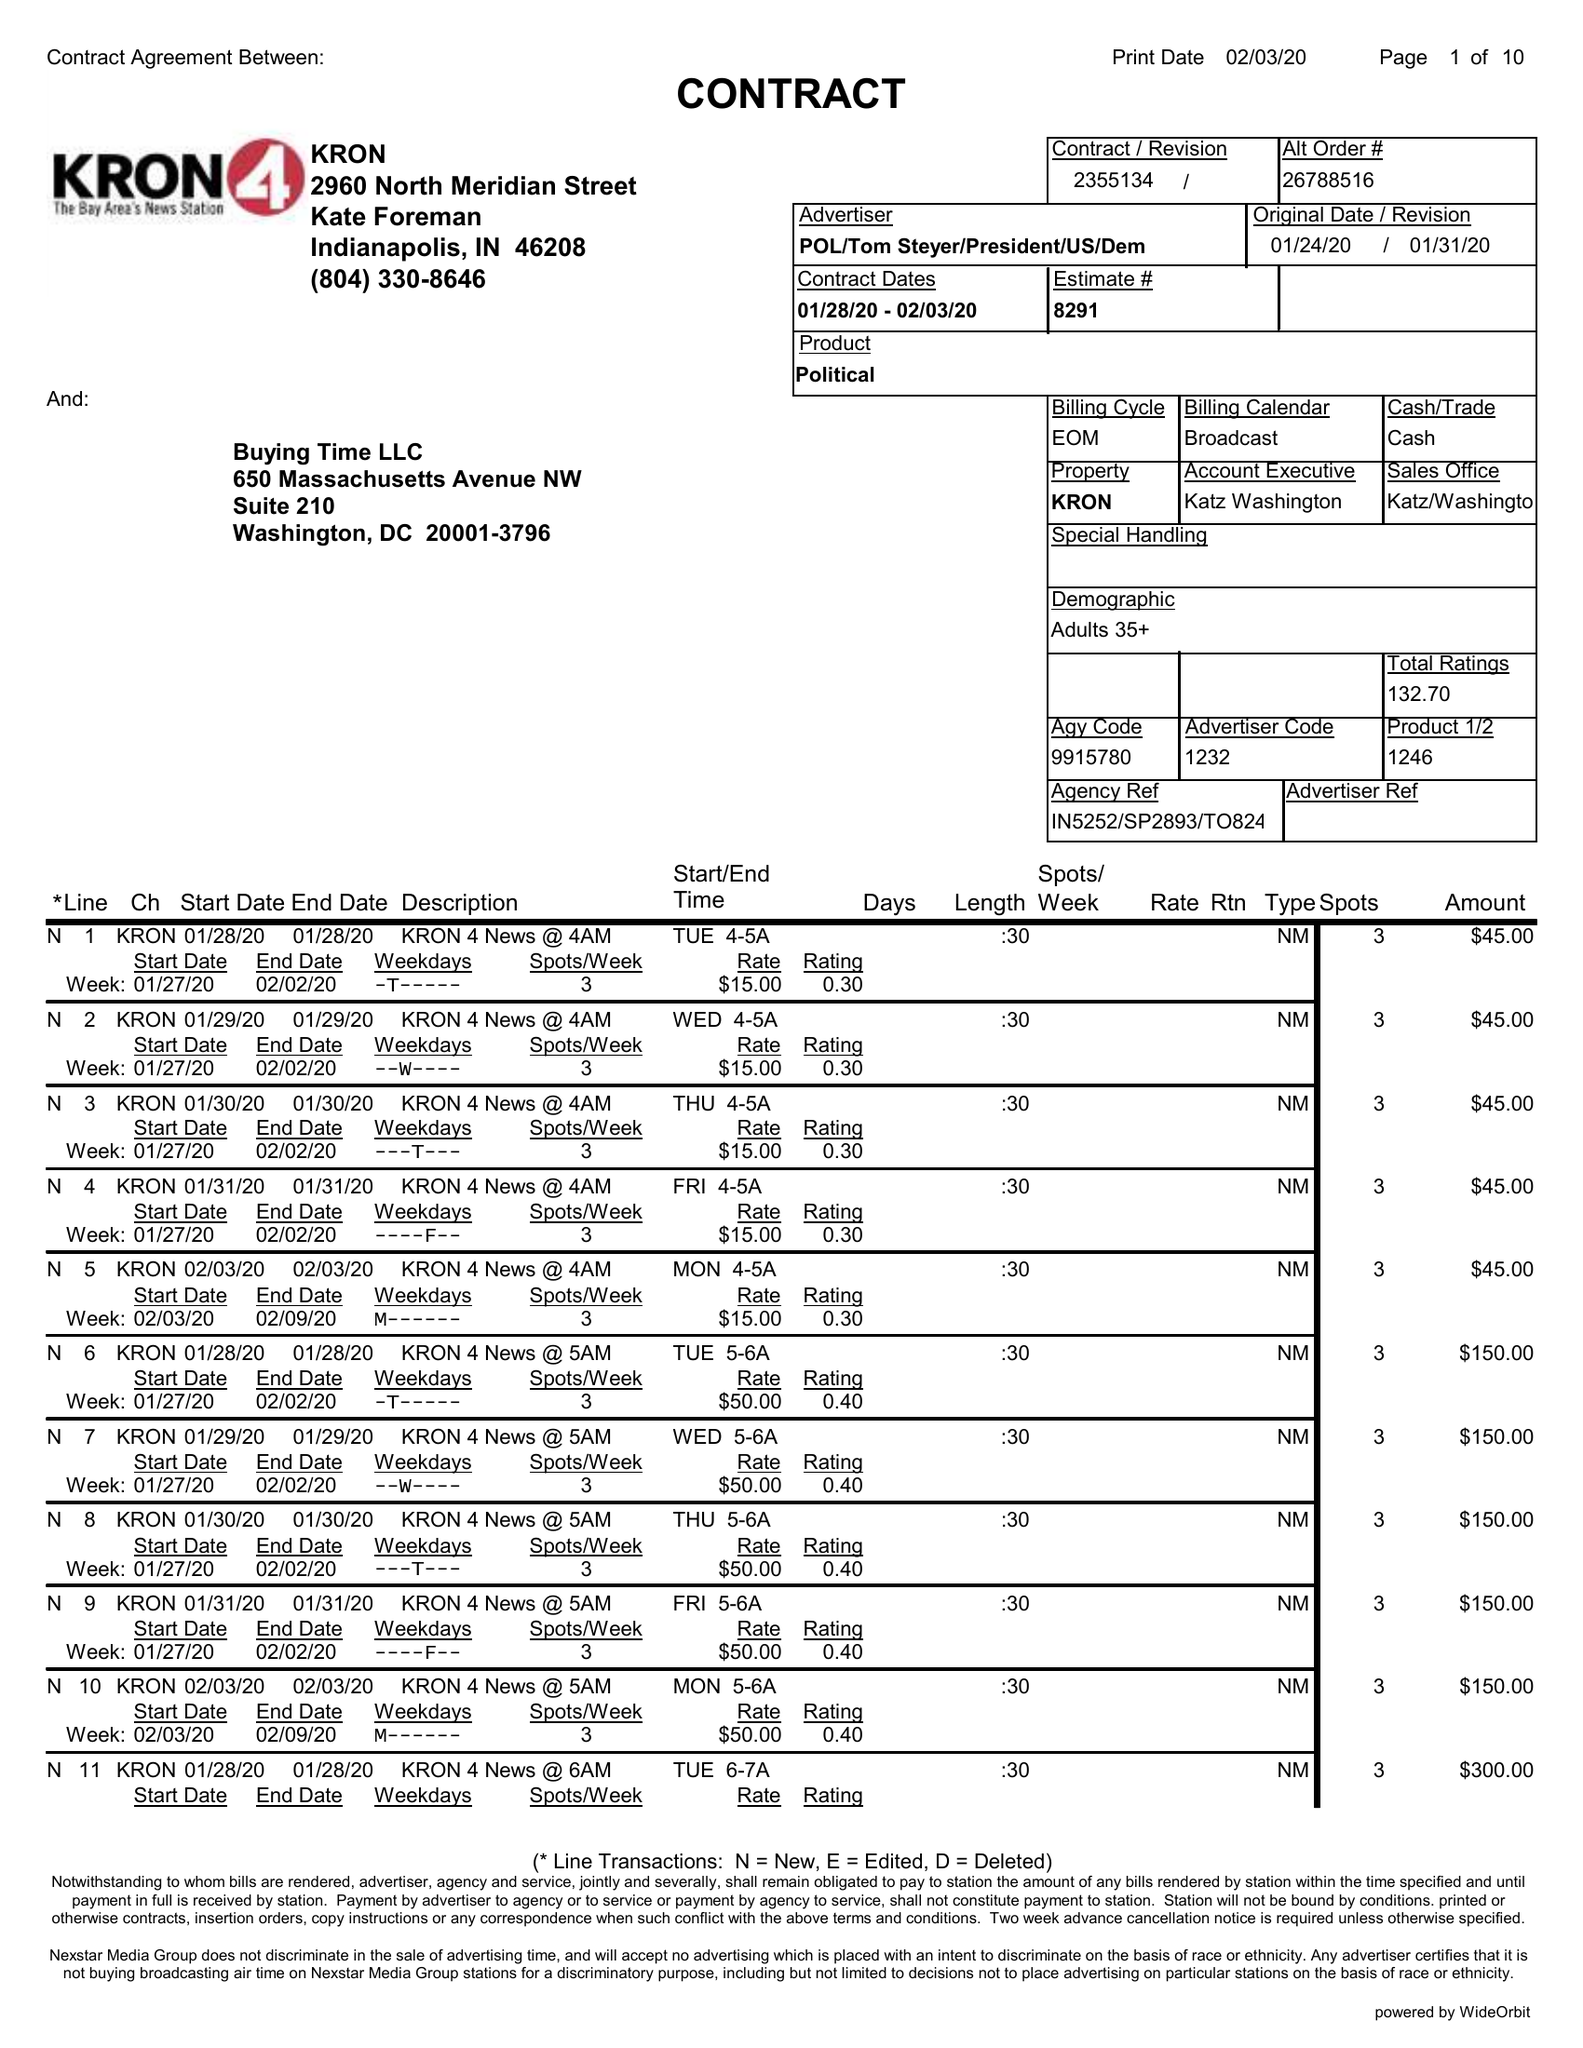What is the value for the flight_to?
Answer the question using a single word or phrase. 02/03/20 